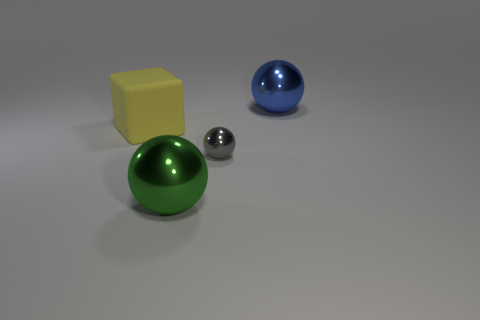Can you tell me what the lighting in the scene suggests about the location of these objects? The lighting in the scene is soft and diffused, hinting that the objects might be in a controlled indoor environment. The absence of harsh shadows suggests the presence of a light source that has been evenly distributed across the scene.  How do the objects' colors contribute to the image's overall aesthetic? The objects' colors, featuring primary and secondary hues, interact to create a pleasing and balanced composition. The green and blue spheres make a cool visual contrast with the warm yellow cube, while the metallic sphere adds a neutral yet reflective quality that ties the scene together. 